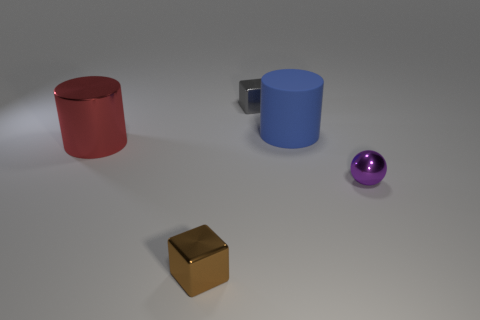What number of small brown cubes are there?
Your answer should be compact. 1. There is a object behind the blue rubber thing; is it the same size as the purple thing?
Give a very brief answer. Yes. What number of metallic things are either tiny spheres or cubes?
Your response must be concise. 3. There is a tiny cube behind the metal cylinder; how many rubber objects are in front of it?
Offer a terse response. 1. There is a shiny object that is in front of the red cylinder and on the left side of the purple shiny ball; what shape is it?
Give a very brief answer. Cube. There is a big thing right of the small shiny cube that is behind the tiny shiny cube that is in front of the shiny cylinder; what is its material?
Give a very brief answer. Rubber. What is the material of the tiny ball?
Keep it short and to the point. Metal. Does the big red cylinder have the same material as the small thing in front of the purple metal thing?
Provide a short and direct response. Yes. There is a cylinder to the right of the small cube that is behind the small brown shiny thing; what is its color?
Make the answer very short. Blue. What is the size of the thing that is both behind the purple shiny thing and in front of the blue thing?
Your answer should be compact. Large. 